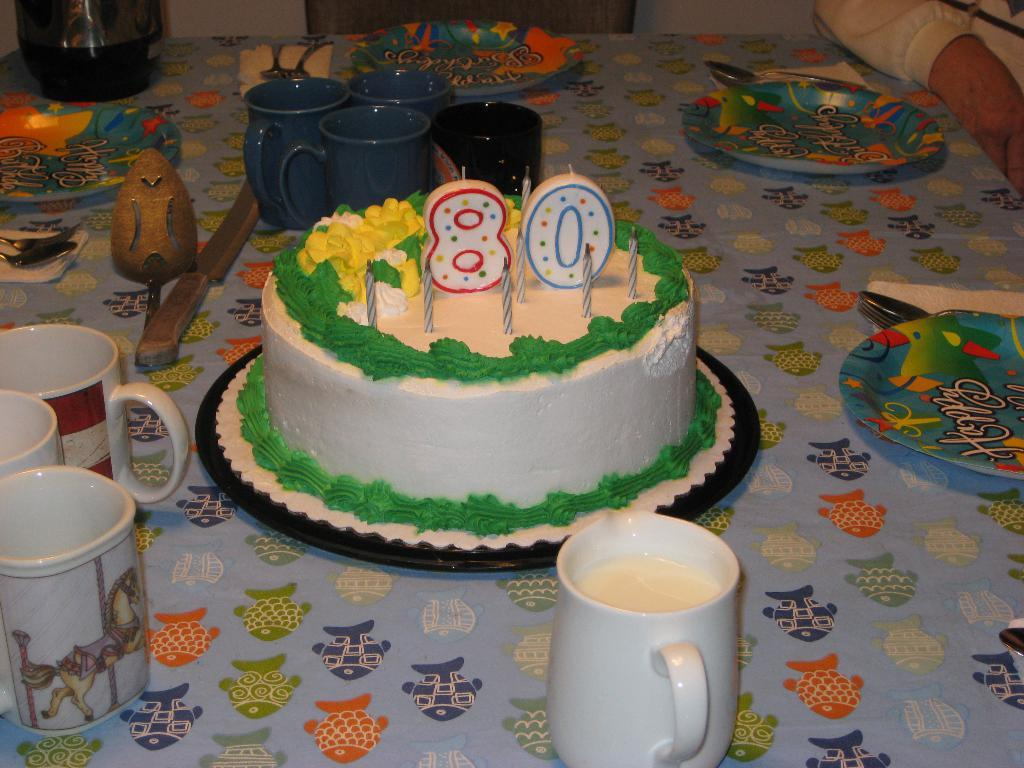What is the main food item featured in the image? There is a cake in the image. What items are present for serving or consuming the cake? There are cups, a knife, plates, and spoons in the image. Are there any other objects on the table besides those mentioned? Yes, there are additional objects on the table. Can you describe the person in the image? There is a person in the image, but no specific details about their appearance or actions are provided. How does the person in the image care for the icicle? There is no icicle present in the image, so it is not possible to answer that question. 